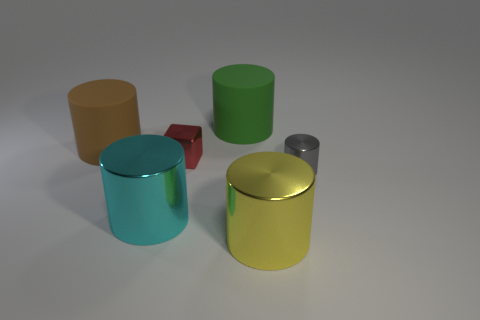How many things are big cyan metallic things or cylinders behind the big yellow metallic cylinder?
Provide a short and direct response. 4. Is there anything else that is the same shape as the cyan metal thing?
Your answer should be compact. Yes. Does the cylinder that is on the right side of the yellow object have the same size as the small red metallic block?
Give a very brief answer. Yes. How many shiny objects are tiny yellow things or brown objects?
Offer a very short reply. 0. There is a shiny cylinder that is on the left side of the green cylinder; what is its size?
Provide a short and direct response. Large. Does the yellow object have the same shape as the green rubber thing?
Your response must be concise. Yes. How many tiny things are yellow metallic cylinders or brown shiny cylinders?
Provide a succinct answer. 0. There is a large yellow object; are there any big cyan metal cylinders right of it?
Provide a succinct answer. No. Is the number of big cyan shiny cylinders that are to the left of the large green matte cylinder the same as the number of large brown things?
Provide a succinct answer. Yes. There is a cyan shiny thing that is the same shape as the large green rubber object; what size is it?
Keep it short and to the point. Large. 